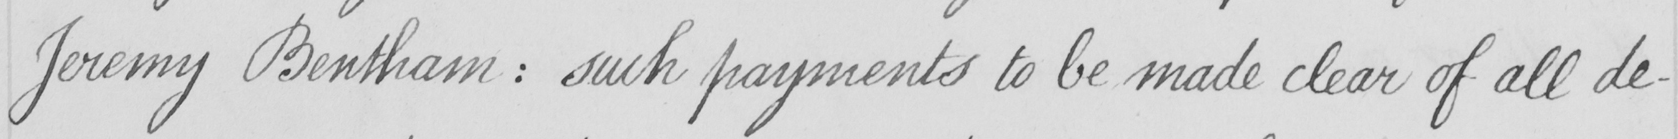What text is written in this handwritten line? Jeremy Bentham  :  such payments to be made clear of all de- 